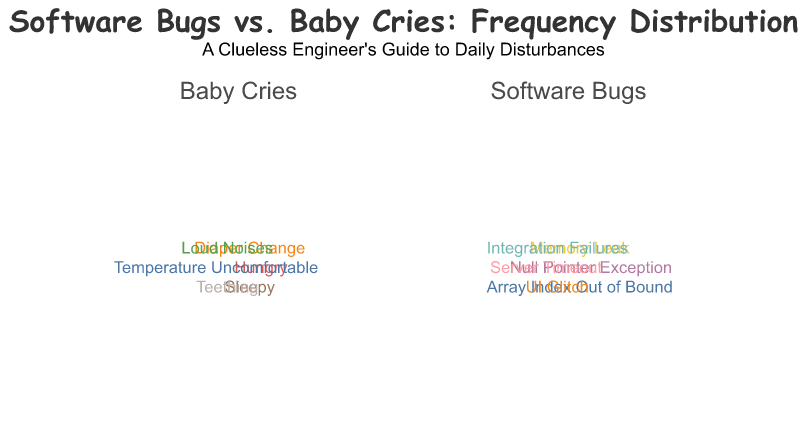What are the two categories represented in the plot? The figure is divided into two main sections: one for "Software Bugs" and another for "Baby Cries." These categories are represented as subplots in the Polar Chart.
Answer: Software Bugs, Baby Cries Which disturbance has the highest frequency in the "Baby Cries" category? By observing the radial length of arcs in the "Baby Cries" part of the plot, the "Sleepy" label extends the farthest, indicating the highest frequency.
Answer: Sleepy How many disturbances related to "Software Bugs" have a frequency of 3? In the "Software Bugs" subplot, we see that "Memory Leak" and "Server Timeout" both have arcs with a frequency of 3.
Answer: 2 Compare the frequency of "Array Index Out of Bound" in "Software Bugs" with "Hungry" in "Baby Cries". Which one is higher? "Array Index Out of Bound" has a frequency of 5, while "Hungry" in "Baby Cries" has a frequency of 6. By comparing these two values directly, we see that "Hungry" is higher.
Answer: Hungry Which disturbance in the "Software Bugs" category has the lowest frequency? Observing the radial lengths of the arcs in "Software Bugs", "Integration Failures" has the shortest arc, indicating the lowest frequency of 1.
Answer: Integration Failures What is the combined frequency of "UI Glitch" and "Server Timeout" in the "Software Bugs" subplot? Adding the frequencies: "UI Glitch" (4) + "Server Timeout" (3) = 7.
Answer: 7 Are there any disturbances with the same frequency in both categories? If so, name them. Comparing the frequencies across both subplots, "Teething" in "Baby Cries" and "Null Pointer Exception" in "Software Bugs" both have a frequency of 2.
Answer: Teething, Null Pointer Exception What is the total frequency of disturbances in "Baby Cries"? Sum of all frequencies in "Baby Cries": 4 (Diaper Change) + 6 (Hungry) + 7 (Sleepy) + 2 (Teething) + 3 (Temperature Uncomfortable) + 5 (Loud Noises) = 27.
Answer: 27 Which category has a higher total frequency of disturbances? Total frequency of "Software Bugs": 3 (Memory Leak) + 2 (Null Pointer Exception) + 5 (Array Index Out of Bound) + 4 (UI Glitch) + 3 (Server Timeout) + 1 (Integration Failures) = 18. Total frequency of "Baby Cries" is 27. Since 27 > 18, "Baby Cries" has a higher total frequency.
Answer: Baby Cries List all disturbances in "Baby Cries" that have a frequency of 5 or above. Observing the radial lengths in "Baby Cries" category, "Hungry" (6), "Sleepy" (7), and "Loud Noises" (5) have frequencies of 5 or above.
Answer: Hungry, Sleepy, Loud Noises 